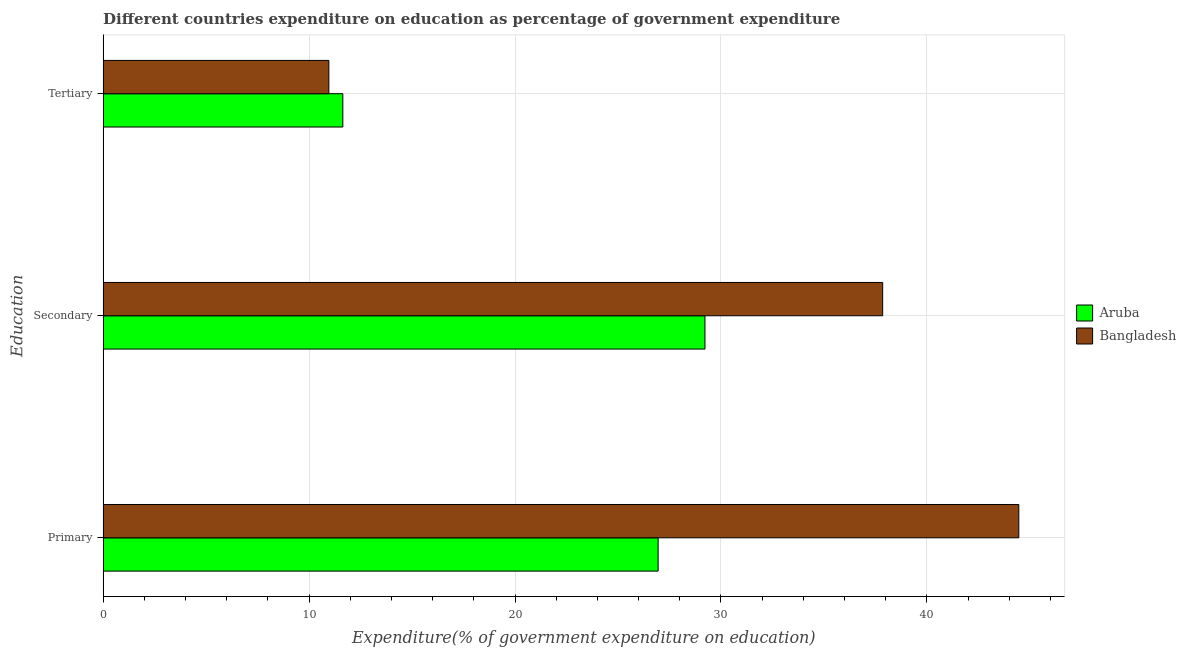How many bars are there on the 1st tick from the top?
Your answer should be compact. 2. What is the label of the 1st group of bars from the top?
Your response must be concise. Tertiary. What is the expenditure on tertiary education in Aruba?
Give a very brief answer. 11.64. Across all countries, what is the maximum expenditure on secondary education?
Provide a succinct answer. 37.85. Across all countries, what is the minimum expenditure on primary education?
Your response must be concise. 26.95. In which country was the expenditure on primary education minimum?
Keep it short and to the point. Aruba. What is the total expenditure on primary education in the graph?
Your answer should be compact. 71.41. What is the difference between the expenditure on secondary education in Aruba and that in Bangladesh?
Provide a succinct answer. -8.63. What is the difference between the expenditure on primary education in Aruba and the expenditure on secondary education in Bangladesh?
Keep it short and to the point. -10.9. What is the average expenditure on tertiary education per country?
Your answer should be compact. 11.3. What is the difference between the expenditure on secondary education and expenditure on tertiary education in Bangladesh?
Provide a short and direct response. 26.89. What is the ratio of the expenditure on secondary education in Bangladesh to that in Aruba?
Provide a succinct answer. 1.3. Is the difference between the expenditure on secondary education in Bangladesh and Aruba greater than the difference between the expenditure on primary education in Bangladesh and Aruba?
Your response must be concise. No. What is the difference between the highest and the second highest expenditure on tertiary education?
Your answer should be compact. 0.68. What is the difference between the highest and the lowest expenditure on primary education?
Offer a very short reply. 17.51. In how many countries, is the expenditure on secondary education greater than the average expenditure on secondary education taken over all countries?
Offer a terse response. 1. What does the 2nd bar from the top in Tertiary represents?
Your answer should be very brief. Aruba. What does the 2nd bar from the bottom in Primary represents?
Your answer should be compact. Bangladesh. Is it the case that in every country, the sum of the expenditure on primary education and expenditure on secondary education is greater than the expenditure on tertiary education?
Provide a succinct answer. Yes. How many bars are there?
Offer a terse response. 6. Are all the bars in the graph horizontal?
Offer a terse response. Yes. How many countries are there in the graph?
Keep it short and to the point. 2. What is the difference between two consecutive major ticks on the X-axis?
Your answer should be compact. 10. Does the graph contain any zero values?
Your answer should be very brief. No. Where does the legend appear in the graph?
Keep it short and to the point. Center right. How many legend labels are there?
Ensure brevity in your answer.  2. How are the legend labels stacked?
Your answer should be compact. Vertical. What is the title of the graph?
Make the answer very short. Different countries expenditure on education as percentage of government expenditure. Does "Afghanistan" appear as one of the legend labels in the graph?
Make the answer very short. No. What is the label or title of the X-axis?
Provide a succinct answer. Expenditure(% of government expenditure on education). What is the label or title of the Y-axis?
Offer a terse response. Education. What is the Expenditure(% of government expenditure on education) in Aruba in Primary?
Keep it short and to the point. 26.95. What is the Expenditure(% of government expenditure on education) in Bangladesh in Primary?
Give a very brief answer. 44.46. What is the Expenditure(% of government expenditure on education) of Aruba in Secondary?
Provide a succinct answer. 29.22. What is the Expenditure(% of government expenditure on education) in Bangladesh in Secondary?
Keep it short and to the point. 37.85. What is the Expenditure(% of government expenditure on education) of Aruba in Tertiary?
Ensure brevity in your answer.  11.64. What is the Expenditure(% of government expenditure on education) in Bangladesh in Tertiary?
Provide a succinct answer. 10.96. Across all Education, what is the maximum Expenditure(% of government expenditure on education) of Aruba?
Offer a very short reply. 29.22. Across all Education, what is the maximum Expenditure(% of government expenditure on education) of Bangladesh?
Your answer should be very brief. 44.46. Across all Education, what is the minimum Expenditure(% of government expenditure on education) of Aruba?
Make the answer very short. 11.64. Across all Education, what is the minimum Expenditure(% of government expenditure on education) of Bangladesh?
Keep it short and to the point. 10.96. What is the total Expenditure(% of government expenditure on education) in Aruba in the graph?
Give a very brief answer. 67.81. What is the total Expenditure(% of government expenditure on education) of Bangladesh in the graph?
Your answer should be compact. 93.28. What is the difference between the Expenditure(% of government expenditure on education) in Aruba in Primary and that in Secondary?
Offer a terse response. -2.27. What is the difference between the Expenditure(% of government expenditure on education) in Bangladesh in Primary and that in Secondary?
Make the answer very short. 6.61. What is the difference between the Expenditure(% of government expenditure on education) in Aruba in Primary and that in Tertiary?
Ensure brevity in your answer.  15.31. What is the difference between the Expenditure(% of government expenditure on education) in Bangladesh in Primary and that in Tertiary?
Make the answer very short. 33.5. What is the difference between the Expenditure(% of government expenditure on education) of Aruba in Secondary and that in Tertiary?
Give a very brief answer. 17.58. What is the difference between the Expenditure(% of government expenditure on education) of Bangladesh in Secondary and that in Tertiary?
Keep it short and to the point. 26.89. What is the difference between the Expenditure(% of government expenditure on education) in Aruba in Primary and the Expenditure(% of government expenditure on education) in Bangladesh in Secondary?
Ensure brevity in your answer.  -10.9. What is the difference between the Expenditure(% of government expenditure on education) of Aruba in Primary and the Expenditure(% of government expenditure on education) of Bangladesh in Tertiary?
Offer a very short reply. 15.99. What is the difference between the Expenditure(% of government expenditure on education) of Aruba in Secondary and the Expenditure(% of government expenditure on education) of Bangladesh in Tertiary?
Your response must be concise. 18.26. What is the average Expenditure(% of government expenditure on education) in Aruba per Education?
Ensure brevity in your answer.  22.6. What is the average Expenditure(% of government expenditure on education) of Bangladesh per Education?
Keep it short and to the point. 31.09. What is the difference between the Expenditure(% of government expenditure on education) of Aruba and Expenditure(% of government expenditure on education) of Bangladesh in Primary?
Make the answer very short. -17.51. What is the difference between the Expenditure(% of government expenditure on education) of Aruba and Expenditure(% of government expenditure on education) of Bangladesh in Secondary?
Your answer should be compact. -8.63. What is the difference between the Expenditure(% of government expenditure on education) of Aruba and Expenditure(% of government expenditure on education) of Bangladesh in Tertiary?
Ensure brevity in your answer.  0.68. What is the ratio of the Expenditure(% of government expenditure on education) in Aruba in Primary to that in Secondary?
Provide a succinct answer. 0.92. What is the ratio of the Expenditure(% of government expenditure on education) in Bangladesh in Primary to that in Secondary?
Your response must be concise. 1.17. What is the ratio of the Expenditure(% of government expenditure on education) in Aruba in Primary to that in Tertiary?
Provide a succinct answer. 2.32. What is the ratio of the Expenditure(% of government expenditure on education) of Bangladesh in Primary to that in Tertiary?
Your answer should be compact. 4.06. What is the ratio of the Expenditure(% of government expenditure on education) of Aruba in Secondary to that in Tertiary?
Offer a very short reply. 2.51. What is the ratio of the Expenditure(% of government expenditure on education) of Bangladesh in Secondary to that in Tertiary?
Offer a terse response. 3.45. What is the difference between the highest and the second highest Expenditure(% of government expenditure on education) of Aruba?
Offer a terse response. 2.27. What is the difference between the highest and the second highest Expenditure(% of government expenditure on education) of Bangladesh?
Offer a terse response. 6.61. What is the difference between the highest and the lowest Expenditure(% of government expenditure on education) in Aruba?
Give a very brief answer. 17.58. What is the difference between the highest and the lowest Expenditure(% of government expenditure on education) in Bangladesh?
Make the answer very short. 33.5. 